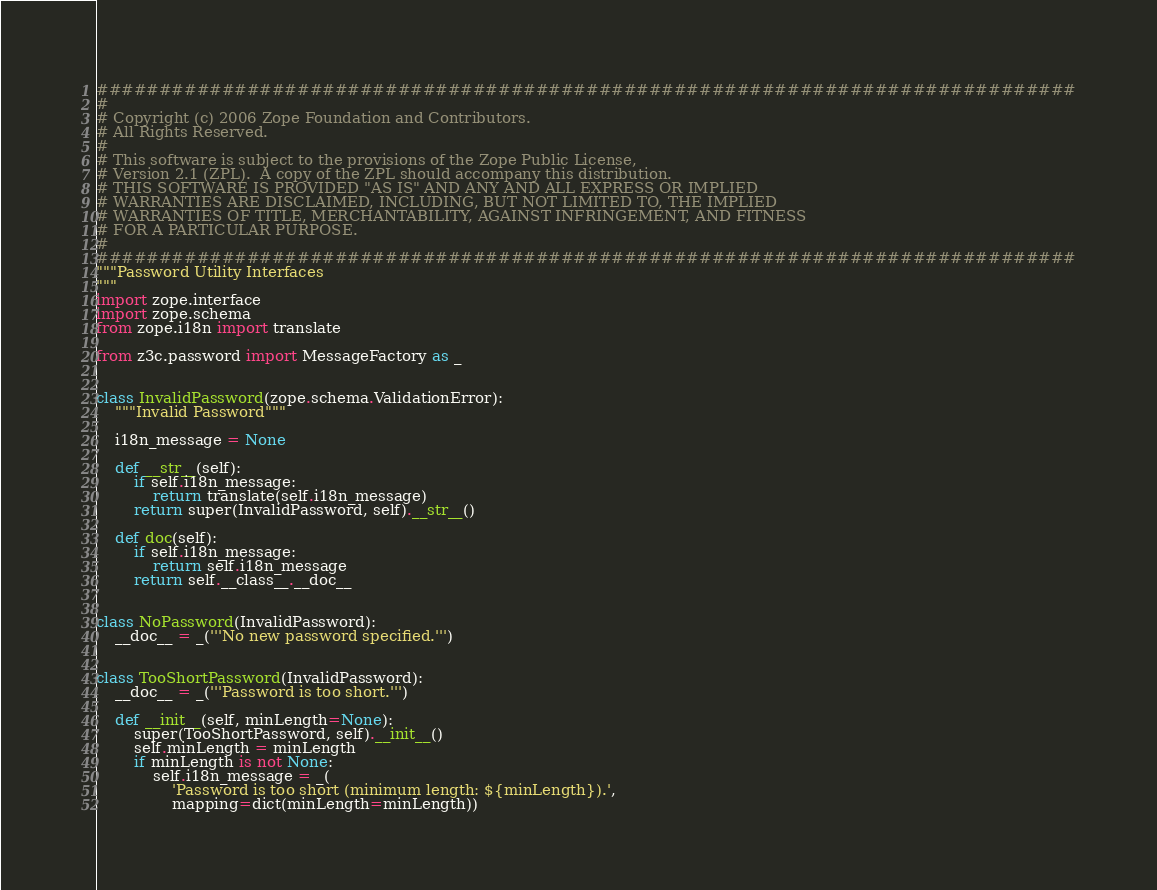<code> <loc_0><loc_0><loc_500><loc_500><_Python_>##############################################################################
#
# Copyright (c) 2006 Zope Foundation and Contributors.
# All Rights Reserved.
#
# This software is subject to the provisions of the Zope Public License,
# Version 2.1 (ZPL).  A copy of the ZPL should accompany this distribution.
# THIS SOFTWARE IS PROVIDED "AS IS" AND ANY AND ALL EXPRESS OR IMPLIED
# WARRANTIES ARE DISCLAIMED, INCLUDING, BUT NOT LIMITED TO, THE IMPLIED
# WARRANTIES OF TITLE, MERCHANTABILITY, AGAINST INFRINGEMENT, AND FITNESS
# FOR A PARTICULAR PURPOSE.
#
##############################################################################
"""Password Utility Interfaces
"""
import zope.interface
import zope.schema
from zope.i18n import translate

from z3c.password import MessageFactory as _


class InvalidPassword(zope.schema.ValidationError):
    """Invalid Password"""

    i18n_message = None

    def __str__(self):
        if self.i18n_message:
            return translate(self.i18n_message)
        return super(InvalidPassword, self).__str__()

    def doc(self):
        if self.i18n_message:
            return self.i18n_message
        return self.__class__.__doc__


class NoPassword(InvalidPassword):
    __doc__ = _('''No new password specified.''')


class TooShortPassword(InvalidPassword):
    __doc__ = _('''Password is too short.''')

    def __init__(self, minLength=None):
        super(TooShortPassword, self).__init__()
        self.minLength = minLength
        if minLength is not None:
            self.i18n_message = _(
                'Password is too short (minimum length: ${minLength}).',
                mapping=dict(minLength=minLength))

</code> 